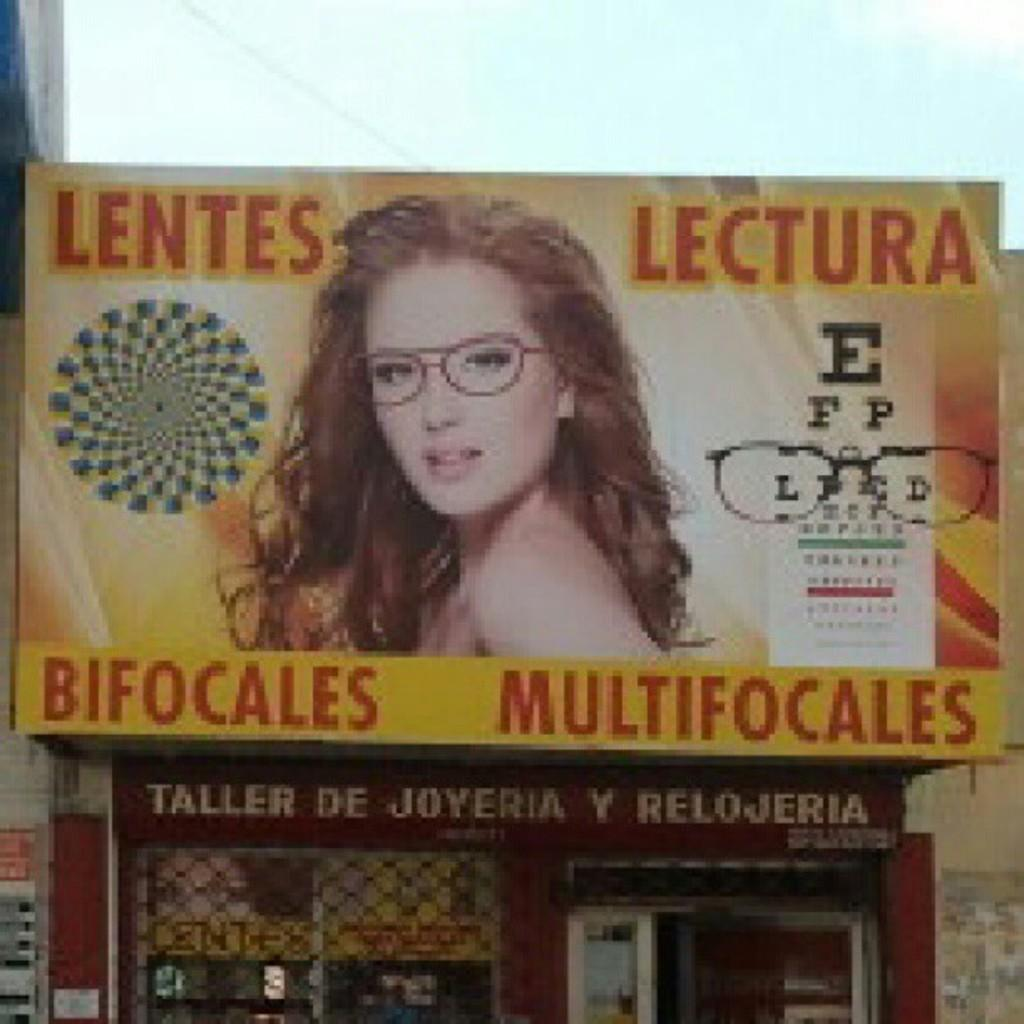What is the main subject in the middle of the image? There is a hoarding in the middle of the image. What can be seen on the hoarding? The hoarding features a woman with spectacles on her eyes. What type of establishment is located at the bottom of the image? There is a shop at the bottom of the image. How far away is the pump from the hoarding in the image? There is no pump present in the image, so it is not possible to determine the distance between a pump and the hoarding. 